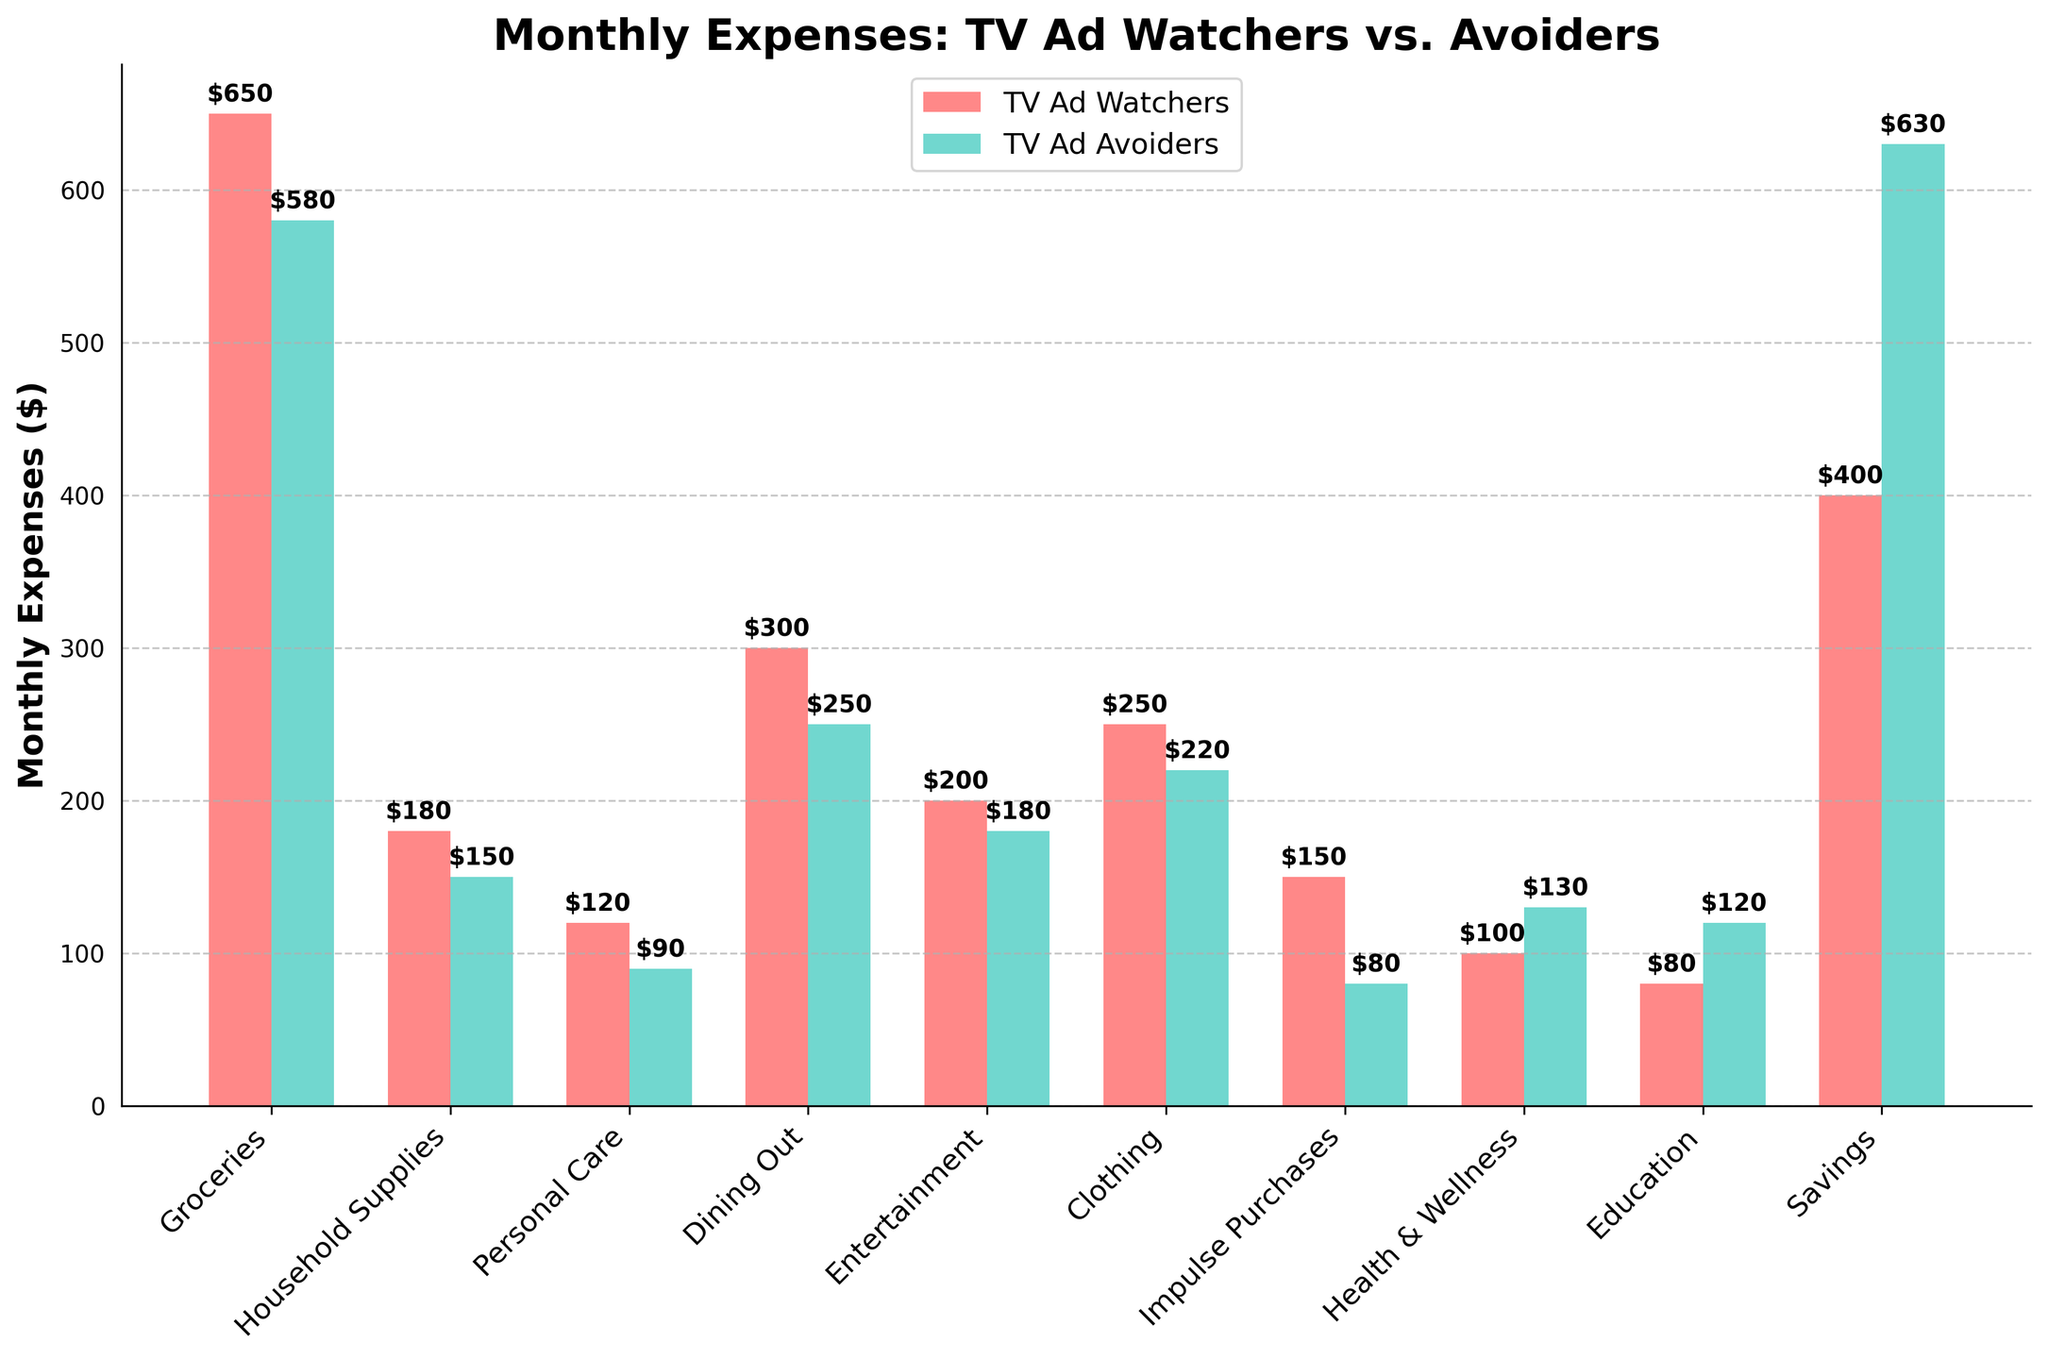What's the difference in monthly savings between TV Ad Watchers and TV Ad Avoiders? Look at the "Savings" category. TV Ad Watchers save $400, while TV Ad Avoiders save $630. Subtract $400 from $630: $630 - $400 = $230.
Answer: $230 Which group spends more on groceries? Compare the heights of the "Groceries" bars. TV Ad Watchers spend $650, TV Ad Avoiders spend $580.
Answer: TV Ad Watchers What is the combined expenditure on dining out and entertainment for TV Ad Watchers? Sum the "Dining Out" and "Entertainment" expenses for TV Ad Watchers: $300 (Dining Out) + $200 (Entertainment) = $500.
Answer: $500 By how much do TV Ad Avoiders exceed TV Ad Watchers on health & wellness expenses? Look at the "Health & Wellness" category. TV Ad Avoiders spend $130, TV Ad Watchers spend $100. Subtract $100 from $130: $130 - $100 = $30.
Answer: $30 Which category shows the least expenditure difference between TV Ad Watchers and TV Ad Avoiders? Calculate the differences for all categories and find the smallest. (Example: Groceries $70, Household Supplies $30, Personal Care $30, etc.). The Health & Wellness category has a difference of $30.
Answer: Health & Wellness What’s the total expenditure on clothing and personal care for TV Ad Avoiders? Sum the "Clothing" and "Personal Care" expenses for TV Ad Avoiders: $220 (Clothing) + $90 (Personal Care) = $310.
Answer: $310 Which group spends less on impulse purchases? Compare the heights of the "Impulse Purchases" bars. TV Ad Avoiders spend $80, while TV Ad Watchers spend $150.
Answer: TV Ad Avoiders Excluding savings, what’s the average monthly expense for TV Ad Watchers? Sum all expenses for TV Ad Watchers except savings, then divide by the number of categories: ($650 + $180 + $120 + $300 + $200 + $250 + $150 + $100 + $80) = $2030; Average = $2030 / 9 ≈ $225.56.
Answer: $225.56 By how much do TV Ad Watchers outspend TV Ad Avoiders in total on groceries and household supplies? Sum the "Groceries" and "Household Supplies" expenses for both groups, then find the difference: TV Ad Watchers: $650 + $180 = $830; TV Ad Avoiders: $580 + $150 = $730. Difference: $830 - $730 = $100.
Answer: $100 